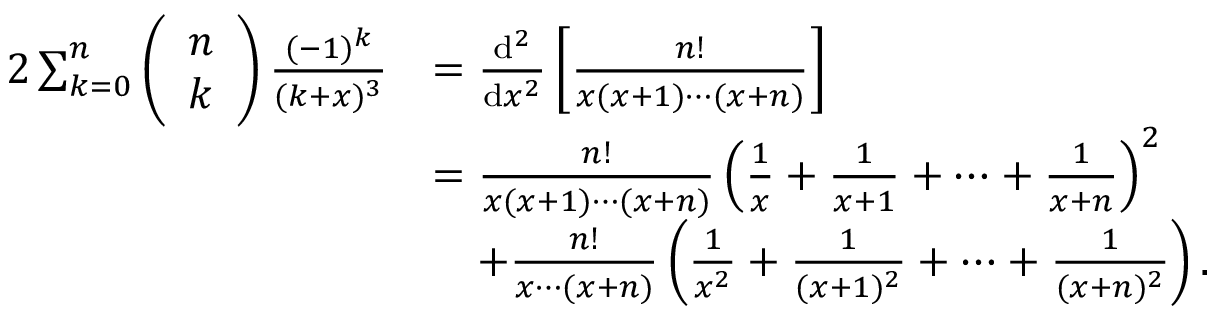Convert formula to latex. <formula><loc_0><loc_0><loc_500><loc_500>\begin{array} { r l } { 2 \sum _ { k = 0 } ^ { n } \left ( \begin{array} { l } { n } \\ { k } \end{array} \right ) \frac { ( - 1 ) ^ { k } } { ( k + x ) ^ { 3 } } } & { = \frac { d ^ { 2 } } { d x ^ { 2 } } \left [ \frac { n ! } { x ( x + 1 ) \cdots ( x + n ) } \right ] } \\ & { = \frac { n ! } { x ( x + 1 ) \cdots ( x + n ) } \left ( \frac { 1 } { x } + \frac { 1 } { x + 1 } + \cdots + \frac { 1 } { x + n } \right ) ^ { 2 } } \\ & { \quad + \frac { n ! } { x \cdots ( x + n ) } \left ( \frac { 1 } { x ^ { 2 } } + \frac { 1 } { ( x + 1 ) ^ { 2 } } + \cdots + \frac { 1 } { ( x + n ) ^ { 2 } } \right ) . } \end{array}</formula> 